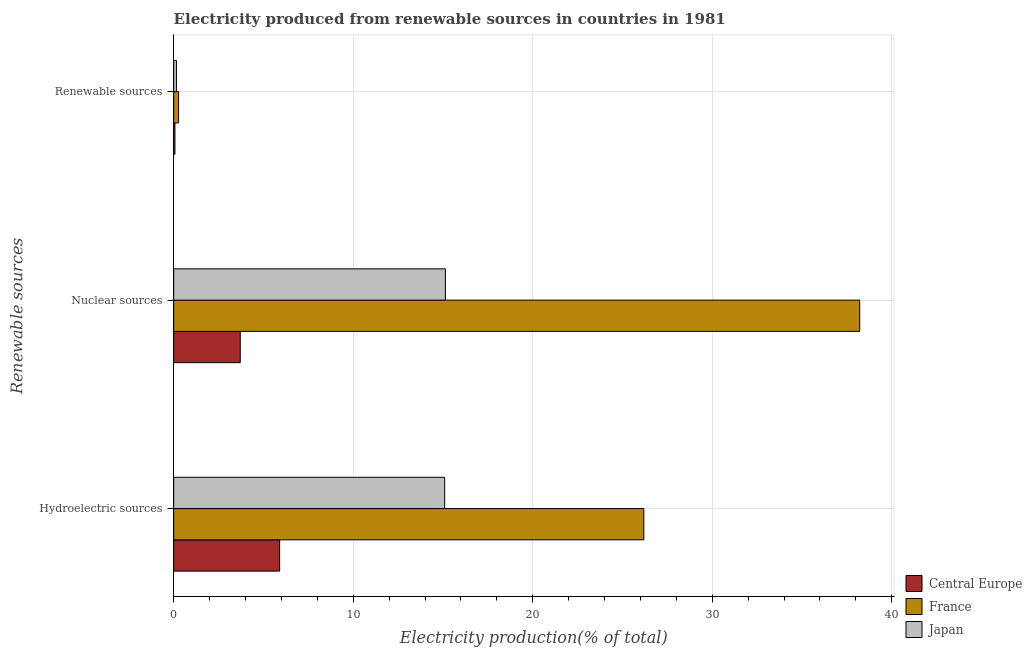How many bars are there on the 3rd tick from the bottom?
Offer a terse response. 3. What is the label of the 3rd group of bars from the top?
Your response must be concise. Hydroelectric sources. What is the percentage of electricity produced by hydroelectric sources in Central Europe?
Offer a terse response. 5.9. Across all countries, what is the maximum percentage of electricity produced by hydroelectric sources?
Ensure brevity in your answer.  26.19. Across all countries, what is the minimum percentage of electricity produced by nuclear sources?
Offer a very short reply. 3.71. In which country was the percentage of electricity produced by renewable sources maximum?
Keep it short and to the point. France. In which country was the percentage of electricity produced by renewable sources minimum?
Ensure brevity in your answer.  Central Europe. What is the total percentage of electricity produced by renewable sources in the graph?
Make the answer very short. 0.5. What is the difference between the percentage of electricity produced by hydroelectric sources in Japan and that in France?
Your answer should be compact. -11.09. What is the difference between the percentage of electricity produced by renewable sources in Japan and the percentage of electricity produced by nuclear sources in France?
Give a very brief answer. -38.06. What is the average percentage of electricity produced by nuclear sources per country?
Provide a succinct answer. 19.02. What is the difference between the percentage of electricity produced by nuclear sources and percentage of electricity produced by hydroelectric sources in France?
Ensure brevity in your answer.  12.02. In how many countries, is the percentage of electricity produced by renewable sources greater than 30 %?
Make the answer very short. 0. What is the ratio of the percentage of electricity produced by renewable sources in Japan to that in Central Europe?
Your response must be concise. 2.21. Is the percentage of electricity produced by renewable sources in Japan less than that in Central Europe?
Your response must be concise. No. What is the difference between the highest and the second highest percentage of electricity produced by nuclear sources?
Offer a terse response. 23.08. What is the difference between the highest and the lowest percentage of electricity produced by hydroelectric sources?
Your answer should be very brief. 20.29. What does the 1st bar from the bottom in Hydroelectric sources represents?
Keep it short and to the point. Central Europe. Are all the bars in the graph horizontal?
Your answer should be compact. Yes. Does the graph contain any zero values?
Keep it short and to the point. No. Does the graph contain grids?
Offer a terse response. Yes. What is the title of the graph?
Provide a short and direct response. Electricity produced from renewable sources in countries in 1981. Does "Switzerland" appear as one of the legend labels in the graph?
Your answer should be compact. No. What is the label or title of the Y-axis?
Give a very brief answer. Renewable sources. What is the Electricity production(% of total) of Central Europe in Hydroelectric sources?
Make the answer very short. 5.9. What is the Electricity production(% of total) in France in Hydroelectric sources?
Your answer should be compact. 26.19. What is the Electricity production(% of total) of Japan in Hydroelectric sources?
Ensure brevity in your answer.  15.1. What is the Electricity production(% of total) in Central Europe in Nuclear sources?
Your answer should be compact. 3.71. What is the Electricity production(% of total) in France in Nuclear sources?
Ensure brevity in your answer.  38.21. What is the Electricity production(% of total) in Japan in Nuclear sources?
Offer a very short reply. 15.13. What is the Electricity production(% of total) in Central Europe in Renewable sources?
Provide a short and direct response. 0.07. What is the Electricity production(% of total) in France in Renewable sources?
Provide a succinct answer. 0.28. What is the Electricity production(% of total) of Japan in Renewable sources?
Your response must be concise. 0.15. Across all Renewable sources, what is the maximum Electricity production(% of total) of Central Europe?
Offer a very short reply. 5.9. Across all Renewable sources, what is the maximum Electricity production(% of total) of France?
Keep it short and to the point. 38.21. Across all Renewable sources, what is the maximum Electricity production(% of total) of Japan?
Your response must be concise. 15.13. Across all Renewable sources, what is the minimum Electricity production(% of total) in Central Europe?
Offer a terse response. 0.07. Across all Renewable sources, what is the minimum Electricity production(% of total) of France?
Your answer should be very brief. 0.28. Across all Renewable sources, what is the minimum Electricity production(% of total) of Japan?
Your answer should be compact. 0.15. What is the total Electricity production(% of total) in Central Europe in the graph?
Your answer should be compact. 9.68. What is the total Electricity production(% of total) in France in the graph?
Provide a succinct answer. 64.68. What is the total Electricity production(% of total) of Japan in the graph?
Offer a very short reply. 30.38. What is the difference between the Electricity production(% of total) in Central Europe in Hydroelectric sources and that in Nuclear sources?
Your answer should be very brief. 2.19. What is the difference between the Electricity production(% of total) of France in Hydroelectric sources and that in Nuclear sources?
Keep it short and to the point. -12.02. What is the difference between the Electricity production(% of total) of Japan in Hydroelectric sources and that in Nuclear sources?
Provide a short and direct response. -0.04. What is the difference between the Electricity production(% of total) in Central Europe in Hydroelectric sources and that in Renewable sources?
Ensure brevity in your answer.  5.83. What is the difference between the Electricity production(% of total) in France in Hydroelectric sources and that in Renewable sources?
Offer a terse response. 25.91. What is the difference between the Electricity production(% of total) of Japan in Hydroelectric sources and that in Renewable sources?
Provide a succinct answer. 14.94. What is the difference between the Electricity production(% of total) in Central Europe in Nuclear sources and that in Renewable sources?
Offer a terse response. 3.64. What is the difference between the Electricity production(% of total) in France in Nuclear sources and that in Renewable sources?
Your response must be concise. 37.94. What is the difference between the Electricity production(% of total) of Japan in Nuclear sources and that in Renewable sources?
Ensure brevity in your answer.  14.98. What is the difference between the Electricity production(% of total) of Central Europe in Hydroelectric sources and the Electricity production(% of total) of France in Nuclear sources?
Offer a very short reply. -32.31. What is the difference between the Electricity production(% of total) in Central Europe in Hydroelectric sources and the Electricity production(% of total) in Japan in Nuclear sources?
Ensure brevity in your answer.  -9.23. What is the difference between the Electricity production(% of total) in France in Hydroelectric sources and the Electricity production(% of total) in Japan in Nuclear sources?
Keep it short and to the point. 11.06. What is the difference between the Electricity production(% of total) in Central Europe in Hydroelectric sources and the Electricity production(% of total) in France in Renewable sources?
Your answer should be compact. 5.63. What is the difference between the Electricity production(% of total) in Central Europe in Hydroelectric sources and the Electricity production(% of total) in Japan in Renewable sources?
Your response must be concise. 5.75. What is the difference between the Electricity production(% of total) in France in Hydroelectric sources and the Electricity production(% of total) in Japan in Renewable sources?
Give a very brief answer. 26.04. What is the difference between the Electricity production(% of total) in Central Europe in Nuclear sources and the Electricity production(% of total) in France in Renewable sources?
Your response must be concise. 3.43. What is the difference between the Electricity production(% of total) of Central Europe in Nuclear sources and the Electricity production(% of total) of Japan in Renewable sources?
Give a very brief answer. 3.55. What is the difference between the Electricity production(% of total) of France in Nuclear sources and the Electricity production(% of total) of Japan in Renewable sources?
Provide a short and direct response. 38.06. What is the average Electricity production(% of total) of Central Europe per Renewable sources?
Your response must be concise. 3.23. What is the average Electricity production(% of total) of France per Renewable sources?
Keep it short and to the point. 21.56. What is the average Electricity production(% of total) of Japan per Renewable sources?
Provide a short and direct response. 10.13. What is the difference between the Electricity production(% of total) in Central Europe and Electricity production(% of total) in France in Hydroelectric sources?
Your answer should be very brief. -20.29. What is the difference between the Electricity production(% of total) in Central Europe and Electricity production(% of total) in Japan in Hydroelectric sources?
Your answer should be very brief. -9.19. What is the difference between the Electricity production(% of total) in France and Electricity production(% of total) in Japan in Hydroelectric sources?
Provide a succinct answer. 11.09. What is the difference between the Electricity production(% of total) in Central Europe and Electricity production(% of total) in France in Nuclear sources?
Keep it short and to the point. -34.5. What is the difference between the Electricity production(% of total) in Central Europe and Electricity production(% of total) in Japan in Nuclear sources?
Give a very brief answer. -11.43. What is the difference between the Electricity production(% of total) in France and Electricity production(% of total) in Japan in Nuclear sources?
Your answer should be compact. 23.08. What is the difference between the Electricity production(% of total) of Central Europe and Electricity production(% of total) of France in Renewable sources?
Provide a succinct answer. -0.2. What is the difference between the Electricity production(% of total) in Central Europe and Electricity production(% of total) in Japan in Renewable sources?
Your response must be concise. -0.08. What is the difference between the Electricity production(% of total) in France and Electricity production(% of total) in Japan in Renewable sources?
Give a very brief answer. 0.12. What is the ratio of the Electricity production(% of total) in Central Europe in Hydroelectric sources to that in Nuclear sources?
Offer a very short reply. 1.59. What is the ratio of the Electricity production(% of total) of France in Hydroelectric sources to that in Nuclear sources?
Provide a succinct answer. 0.69. What is the ratio of the Electricity production(% of total) of Japan in Hydroelectric sources to that in Nuclear sources?
Your response must be concise. 1. What is the ratio of the Electricity production(% of total) in Central Europe in Hydroelectric sources to that in Renewable sources?
Make the answer very short. 84.34. What is the ratio of the Electricity production(% of total) in France in Hydroelectric sources to that in Renewable sources?
Give a very brief answer. 95.23. What is the ratio of the Electricity production(% of total) of Japan in Hydroelectric sources to that in Renewable sources?
Your answer should be very brief. 97.76. What is the ratio of the Electricity production(% of total) of Central Europe in Nuclear sources to that in Renewable sources?
Your answer should be very brief. 52.98. What is the ratio of the Electricity production(% of total) in France in Nuclear sources to that in Renewable sources?
Make the answer very short. 138.95. What is the ratio of the Electricity production(% of total) of Japan in Nuclear sources to that in Renewable sources?
Offer a very short reply. 98.01. What is the difference between the highest and the second highest Electricity production(% of total) in Central Europe?
Keep it short and to the point. 2.19. What is the difference between the highest and the second highest Electricity production(% of total) of France?
Provide a succinct answer. 12.02. What is the difference between the highest and the second highest Electricity production(% of total) of Japan?
Provide a succinct answer. 0.04. What is the difference between the highest and the lowest Electricity production(% of total) in Central Europe?
Offer a terse response. 5.83. What is the difference between the highest and the lowest Electricity production(% of total) in France?
Make the answer very short. 37.94. What is the difference between the highest and the lowest Electricity production(% of total) in Japan?
Offer a very short reply. 14.98. 